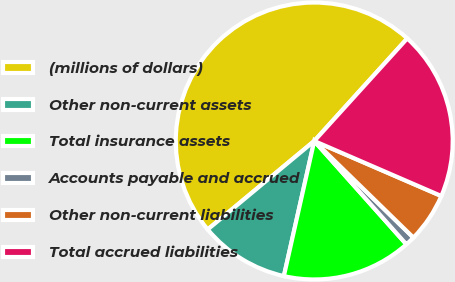Convert chart. <chart><loc_0><loc_0><loc_500><loc_500><pie_chart><fcel>(millions of dollars)<fcel>Other non-current assets<fcel>Total insurance assets<fcel>Accounts payable and accrued<fcel>Other non-current liabilities<fcel>Total accrued liabilities<nl><fcel>47.75%<fcel>10.45%<fcel>15.11%<fcel>1.12%<fcel>5.79%<fcel>19.78%<nl></chart> 